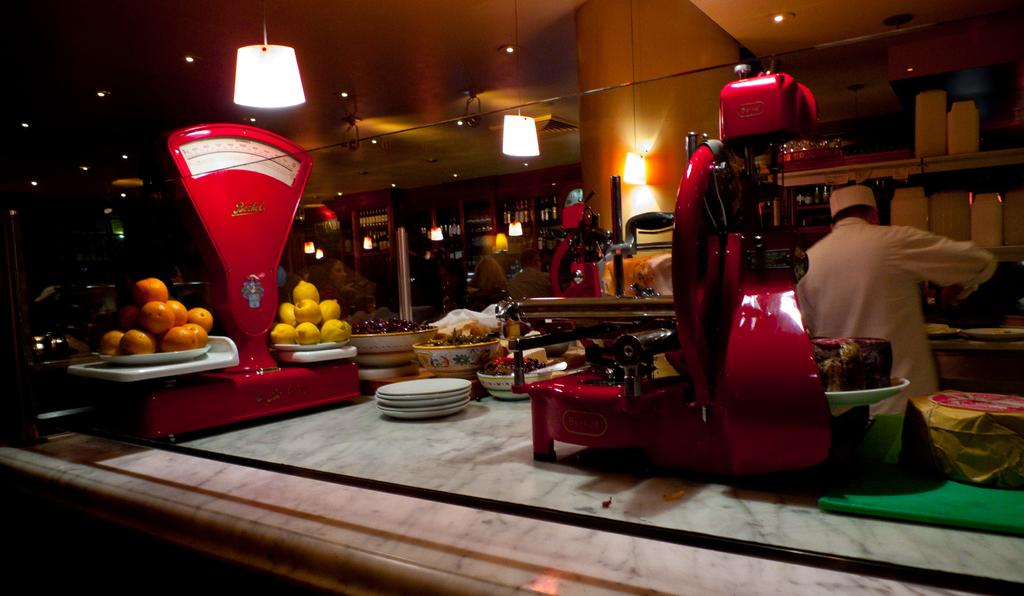What is located at the top of the image? There are lights at the top of the image. What is in the middle of the image? There is a table in the middle of the image. What can be found on the table? There are plates, bowls, and eatables on the table. What is the man on the right side of the image wearing? The man is wearing a white dress. What type of structure can be seen in the image? There is no specific structure mentioned in the provided facts, so it cannot be determined from the image. Are there any corn dishes visible on the table? There is no mention of corn dishes in the provided facts, so it cannot be determined from the image. 